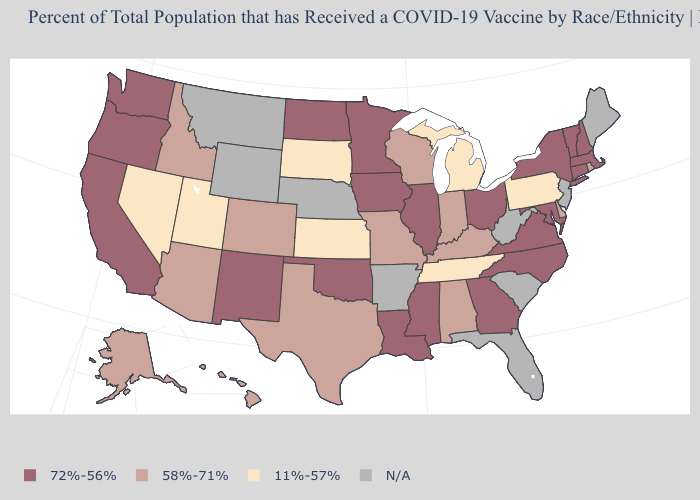Does the first symbol in the legend represent the smallest category?
Write a very short answer. No. Which states hav the highest value in the MidWest?
Answer briefly. Illinois, Iowa, Minnesota, North Dakota, Ohio. What is the value of Utah?
Write a very short answer. 11%-57%. Among the states that border Massachusetts , which have the highest value?
Quick response, please. Connecticut, New Hampshire, New York, Vermont. Does Ohio have the highest value in the USA?
Keep it brief. Yes. What is the value of Rhode Island?
Short answer required. 58%-71%. Among the states that border New York , which have the highest value?
Short answer required. Connecticut, Massachusetts, Vermont. Does Ohio have the highest value in the MidWest?
Quick response, please. Yes. Name the states that have a value in the range 11%-57%?
Answer briefly. Kansas, Michigan, Nevada, Pennsylvania, South Dakota, Tennessee, Utah. Name the states that have a value in the range N/A?
Be succinct. Arkansas, Florida, Maine, Montana, Nebraska, New Jersey, South Carolina, West Virginia, Wyoming. Does Utah have the lowest value in the West?
Be succinct. Yes. What is the value of Utah?
Be succinct. 11%-57%. Does the first symbol in the legend represent the smallest category?
Quick response, please. No. What is the highest value in the USA?
Write a very short answer. 72%-56%. 